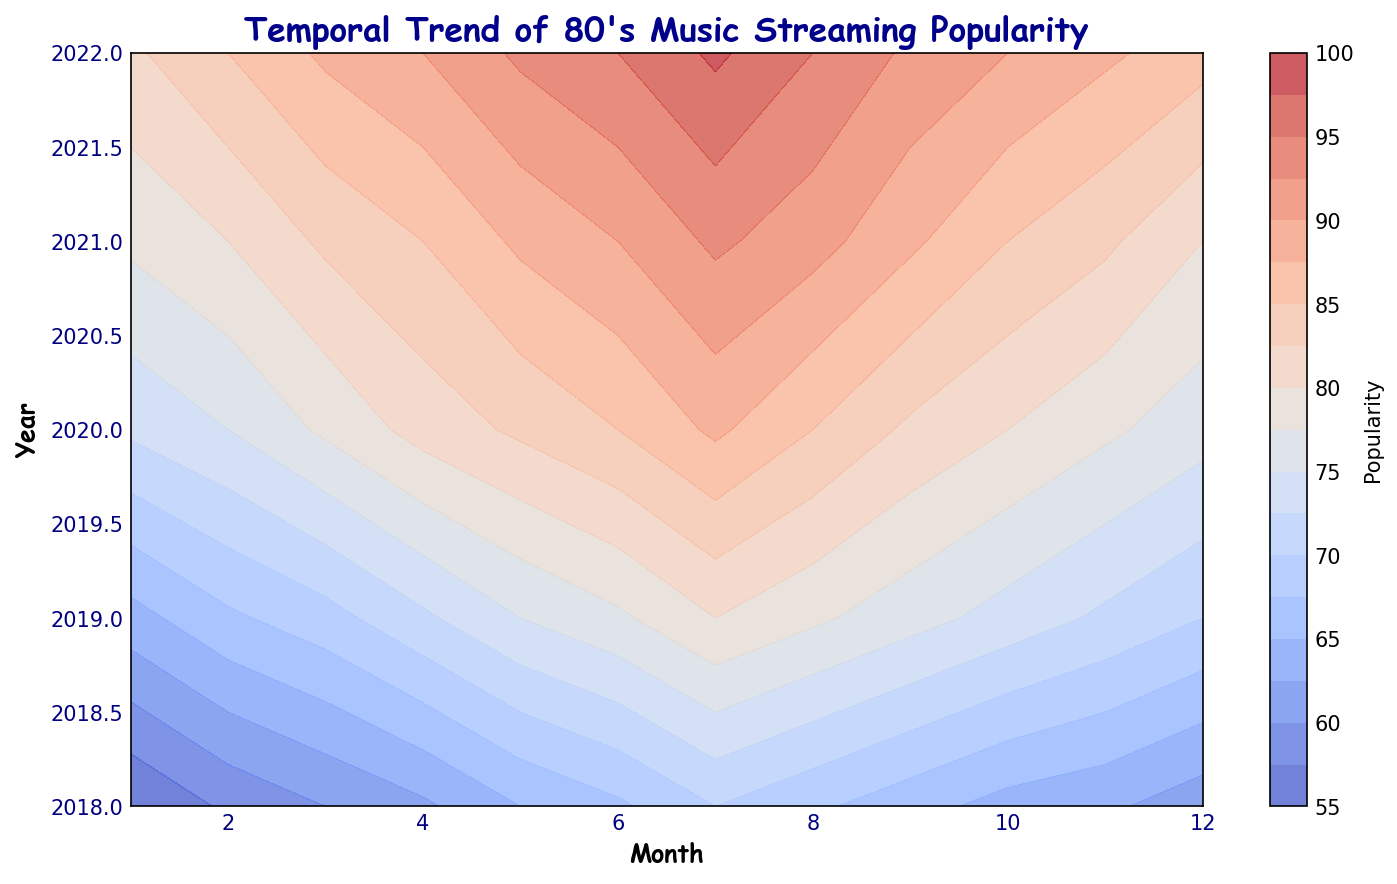What is the peak popularity value observed on the contour plot? The plot shows the popularity of 80's music over the years and months with different shades indicating different levels of popularity. By identifying the brightest section in the contour plot, the peak popularity can be deduced.
Answer: 98 During which month and year was the popularity of 80's music lowest? The contour plot uses darker shades to signify lower popularity. By finding the darkest area, we can pinpoint the specific year and month corresponding to the lowest popularity value.
Answer: January 2018 How does the popularity in July 2021 compare to that in January 2018? Comparing the color intensity between the two dates on the contour plot, July 2021 is represented by a much brighter shade than January 2018, indicating higher popularity.
Answer: Higher In which years did the popularity of 80's music continuously increase every month? Observing the gradient of the contour plot year by year, look for a consistent transition from darker to brighter shades within a single year to identify continuous monthly increases.
Answer: 2021 and 2022 What is the difference in popularity between January 2018 and December 2022? Locate the specific shades for January 2018 and December 2022 on the contour plot to find their popularity values, then compute the difference between them.
Answer: 31 Which year had the highest average popularity? Assess the contour plot for each year by averaging the color intensities (popularity values) of all months within that year to find the year with the highest average.
Answer: 2022 How does the popularity trend from January to July 2020 differ from the same period in 2018? Examine the pattern from January to July for 2020 compared to 2018 on the contour plot. 2020 should show a steeper increase in brightness, indicating a faster rise in popularity.
Answer: Steeper increase in 2020 What months in 2020 have popularity values over 85? Observe the contour plot to identify the months in 2020 represented by shades indicating popularity values over 85.
Answer: June, July, August Which season consistently shows high popularity for 80's music across all years? Look for the recurring brighter areas in the contour plot across different years to determine the season with consistently high popularity (typically July-September, corresponding to summer).
Answer: Summer What's the average increase in popularity for each July from 2018 to 2022? Identify the popularity values for each July from 2018 to 2022 on the contour plot and calculate the yearly differences. Then, compute the average of these differences.
Answer: 8.75 